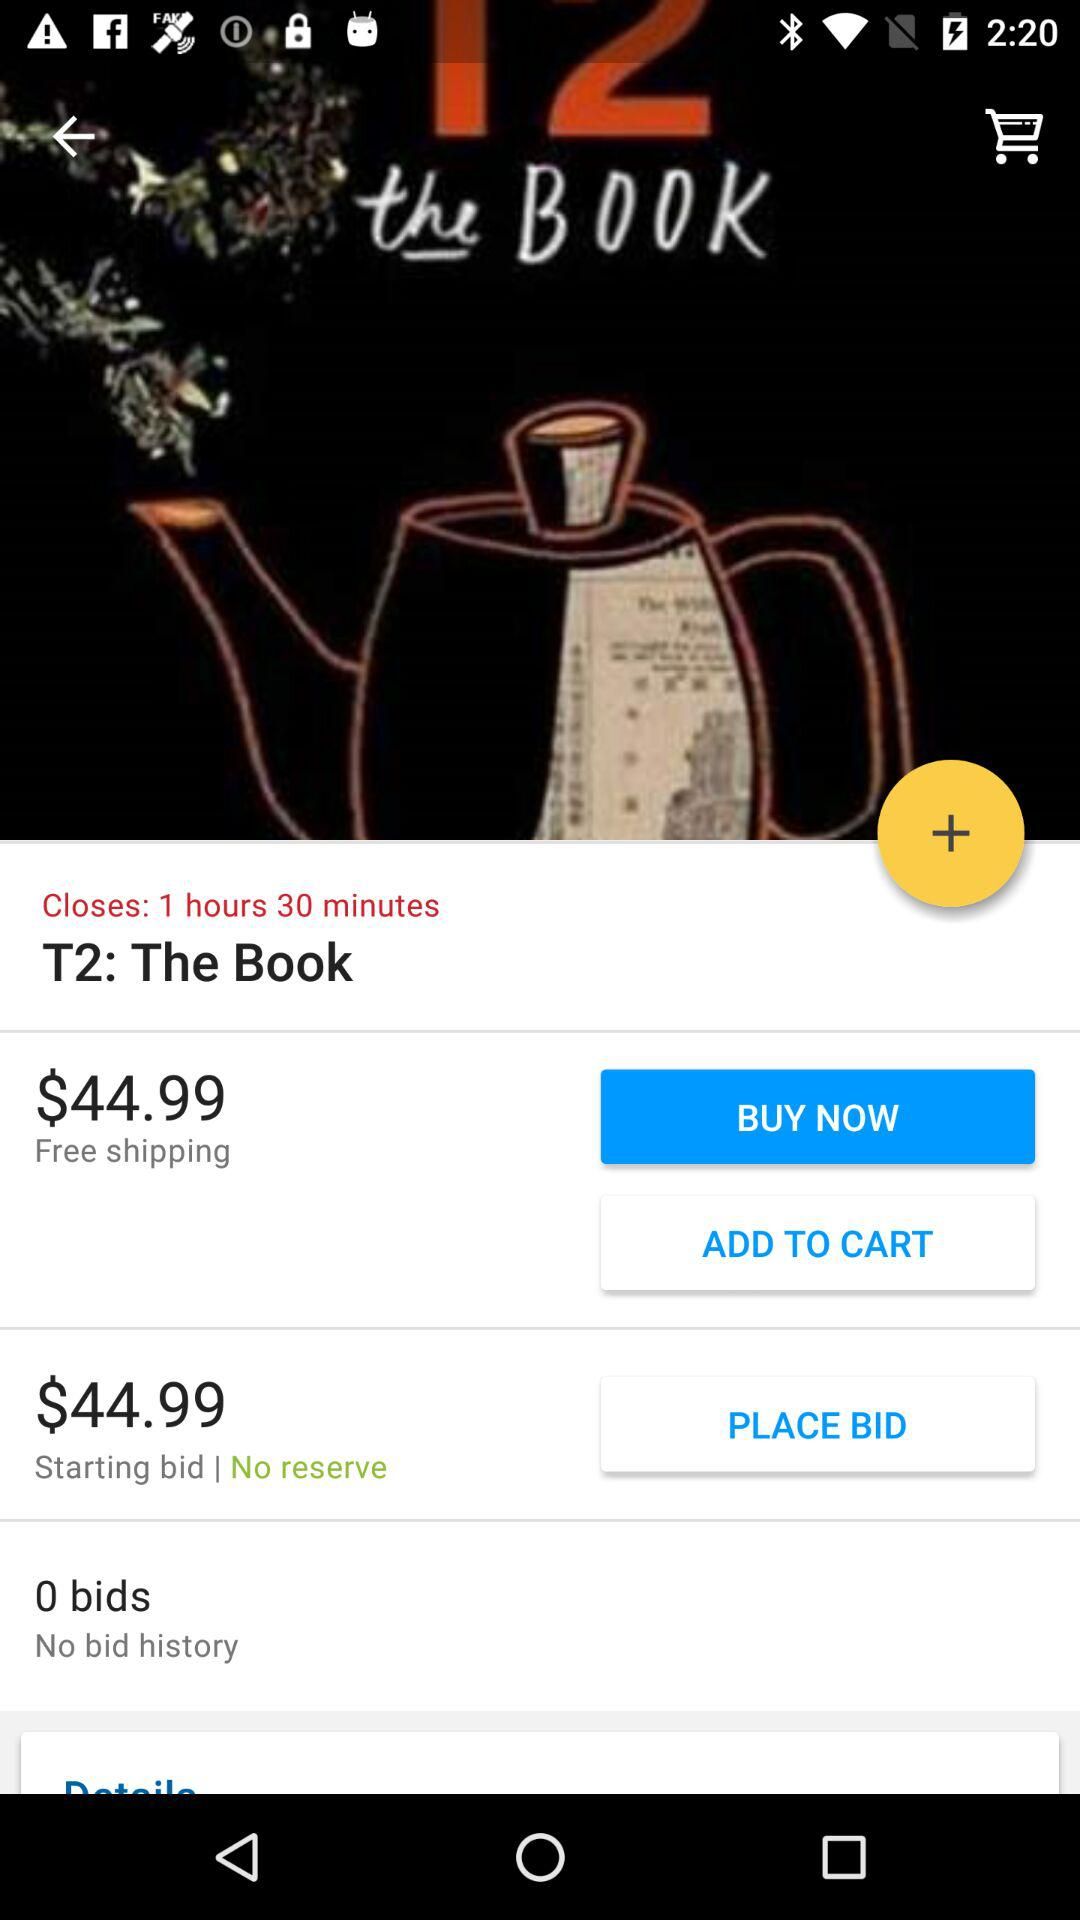Are there any shipping charges?
When the provided information is insufficient, respond with <no answer>. <no answer> 